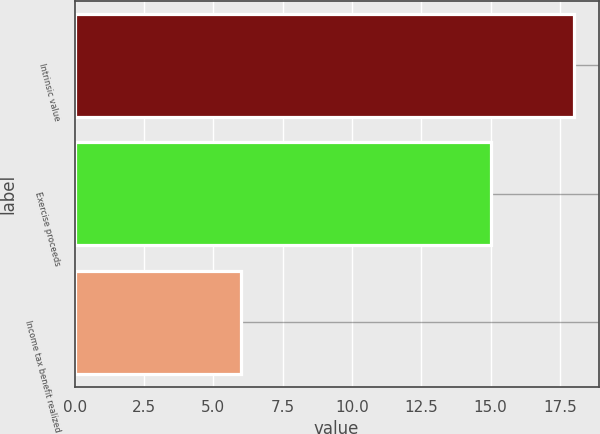<chart> <loc_0><loc_0><loc_500><loc_500><bar_chart><fcel>Intrinsic value<fcel>Exercise proceeds<fcel>Income tax benefit realized<nl><fcel>18<fcel>15<fcel>6<nl></chart> 